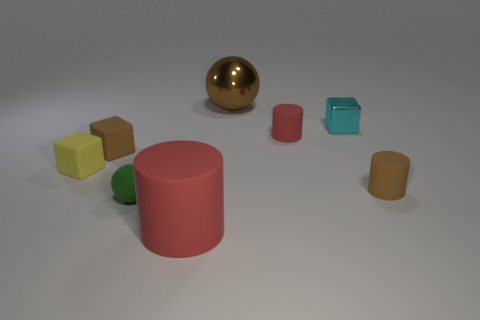Subtract all cylinders. How many objects are left? 5 Subtract 1 balls. How many balls are left? 1 Subtract all gray balls. Subtract all cyan cylinders. How many balls are left? 2 Subtract all purple cylinders. How many green blocks are left? 0 Subtract all tiny shiny objects. Subtract all brown cubes. How many objects are left? 6 Add 4 tiny yellow rubber cubes. How many tiny yellow rubber cubes are left? 5 Add 1 brown matte cubes. How many brown matte cubes exist? 2 Add 2 matte things. How many objects exist? 10 Subtract all red cylinders. How many cylinders are left? 1 Subtract all brown blocks. How many blocks are left? 2 